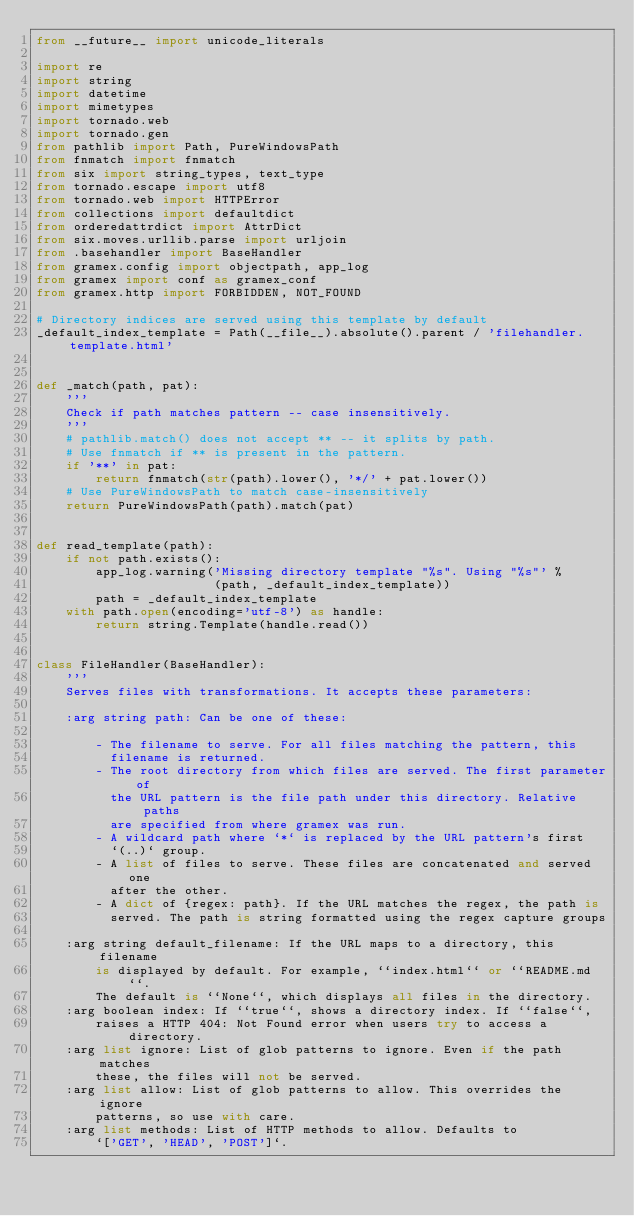Convert code to text. <code><loc_0><loc_0><loc_500><loc_500><_Python_>from __future__ import unicode_literals

import re
import string
import datetime
import mimetypes
import tornado.web
import tornado.gen
from pathlib import Path, PureWindowsPath
from fnmatch import fnmatch
from six import string_types, text_type
from tornado.escape import utf8
from tornado.web import HTTPError
from collections import defaultdict
from orderedattrdict import AttrDict
from six.moves.urllib.parse import urljoin
from .basehandler import BaseHandler
from gramex.config import objectpath, app_log
from gramex import conf as gramex_conf
from gramex.http import FORBIDDEN, NOT_FOUND

# Directory indices are served using this template by default
_default_index_template = Path(__file__).absolute().parent / 'filehandler.template.html'


def _match(path, pat):
    '''
    Check if path matches pattern -- case insensitively.
    '''
    # pathlib.match() does not accept ** -- it splits by path.
    # Use fnmatch if ** is present in the pattern.
    if '**' in pat:
        return fnmatch(str(path).lower(), '*/' + pat.lower())
    # Use PureWindowsPath to match case-insensitively
    return PureWindowsPath(path).match(pat)


def read_template(path):
    if not path.exists():
        app_log.warning('Missing directory template "%s". Using "%s"' %
                        (path, _default_index_template))
        path = _default_index_template
    with path.open(encoding='utf-8') as handle:
        return string.Template(handle.read())


class FileHandler(BaseHandler):
    '''
    Serves files with transformations. It accepts these parameters:

    :arg string path: Can be one of these:

        - The filename to serve. For all files matching the pattern, this
          filename is returned.
        - The root directory from which files are served. The first parameter of
          the URL pattern is the file path under this directory. Relative paths
          are specified from where gramex was run.
        - A wildcard path where `*` is replaced by the URL pattern's first
          `(..)` group.
        - A list of files to serve. These files are concatenated and served one
          after the other.
        - A dict of {regex: path}. If the URL matches the regex, the path is
          served. The path is string formatted using the regex capture groups

    :arg string default_filename: If the URL maps to a directory, this filename
        is displayed by default. For example, ``index.html`` or ``README.md``.
        The default is ``None``, which displays all files in the directory.
    :arg boolean index: If ``true``, shows a directory index. If ``false``,
        raises a HTTP 404: Not Found error when users try to access a directory.
    :arg list ignore: List of glob patterns to ignore. Even if the path matches
        these, the files will not be served.
    :arg list allow: List of glob patterns to allow. This overrides the ignore
        patterns, so use with care.
    :arg list methods: List of HTTP methods to allow. Defaults to
        `['GET', 'HEAD', 'POST']`.</code> 